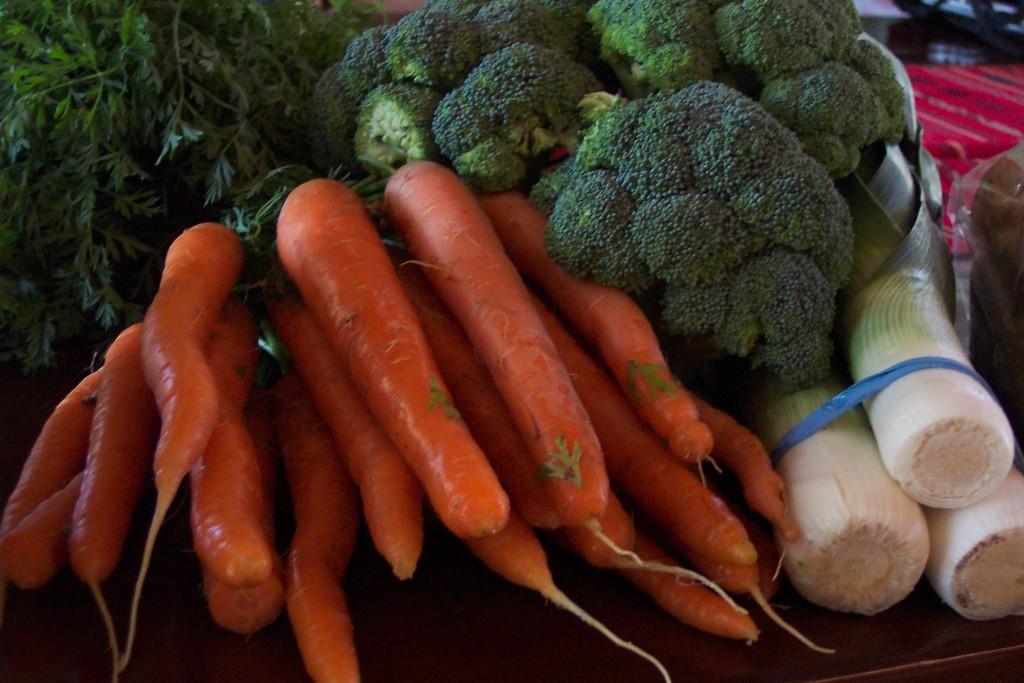Could you give a brief overview of what you see in this image? These are the carrots in the left side of an image and these are the leaves of coriander. 